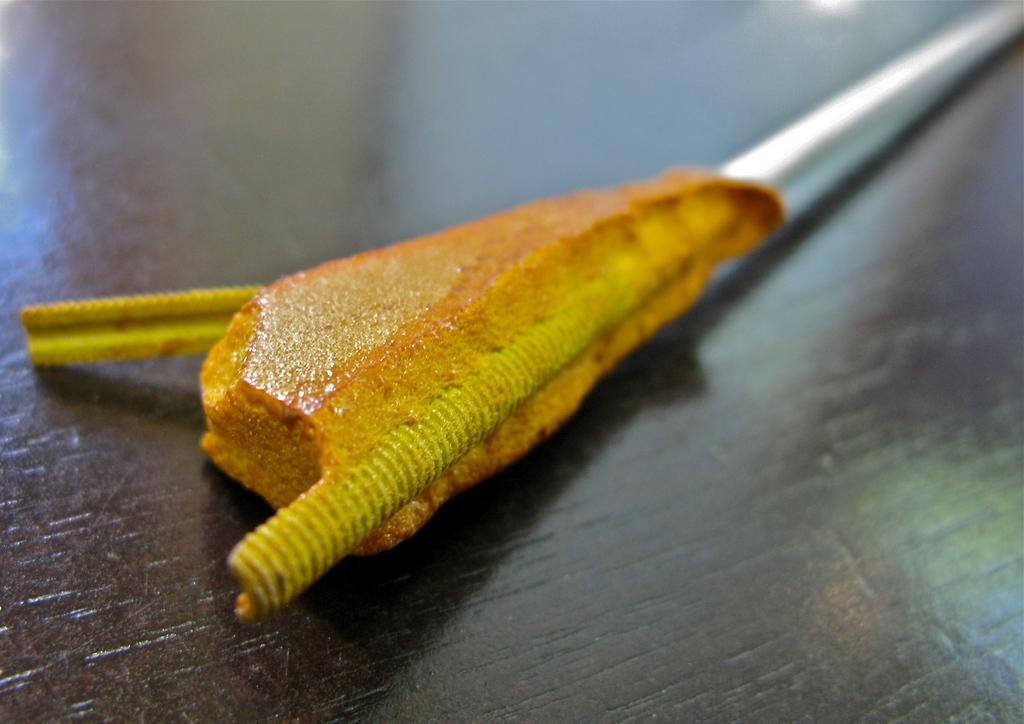What is the main object on the wooden surface in the image? The facts provided do not specify the object on the wooden surface. What can be observed about the image's clarity on the right side and top? The right side and top of the image have a blurry view. What type of treatment is being administered to the object in the image? There is no treatment being administered to any object in the image, as the facts provided do not mention any treatment or medical context. 